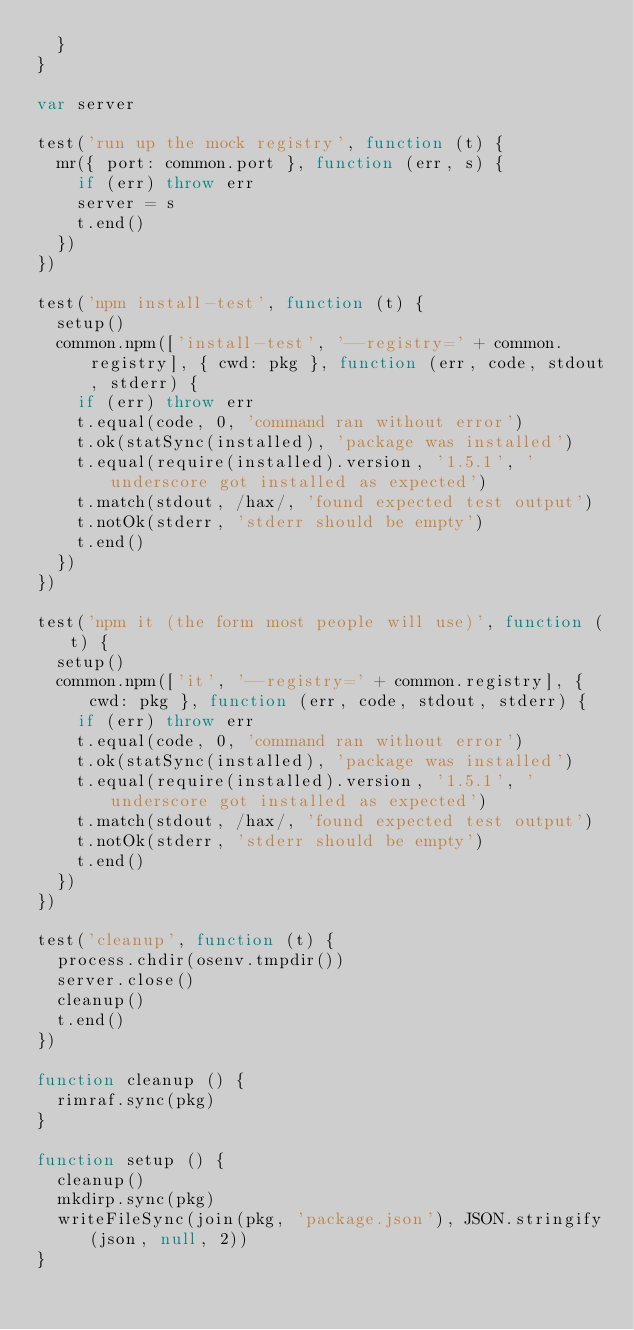<code> <loc_0><loc_0><loc_500><loc_500><_JavaScript_>  }
}

var server

test('run up the mock registry', function (t) {
  mr({ port: common.port }, function (err, s) {
    if (err) throw err
    server = s
    t.end()
  })
})

test('npm install-test', function (t) {
  setup()
  common.npm(['install-test', '--registry=' + common.registry], { cwd: pkg }, function (err, code, stdout, stderr) {
    if (err) throw err
    t.equal(code, 0, 'command ran without error')
    t.ok(statSync(installed), 'package was installed')
    t.equal(require(installed).version, '1.5.1', 'underscore got installed as expected')
    t.match(stdout, /hax/, 'found expected test output')
    t.notOk(stderr, 'stderr should be empty')
    t.end()
  })
})

test('npm it (the form most people will use)', function (t) {
  setup()
  common.npm(['it', '--registry=' + common.registry], { cwd: pkg }, function (err, code, stdout, stderr) {
    if (err) throw err
    t.equal(code, 0, 'command ran without error')
    t.ok(statSync(installed), 'package was installed')
    t.equal(require(installed).version, '1.5.1', 'underscore got installed as expected')
    t.match(stdout, /hax/, 'found expected test output')
    t.notOk(stderr, 'stderr should be empty')
    t.end()
  })
})

test('cleanup', function (t) {
  process.chdir(osenv.tmpdir())
  server.close()
  cleanup()
  t.end()
})

function cleanup () {
  rimraf.sync(pkg)
}

function setup () {
  cleanup()
  mkdirp.sync(pkg)
  writeFileSync(join(pkg, 'package.json'), JSON.stringify(json, null, 2))
}
</code> 